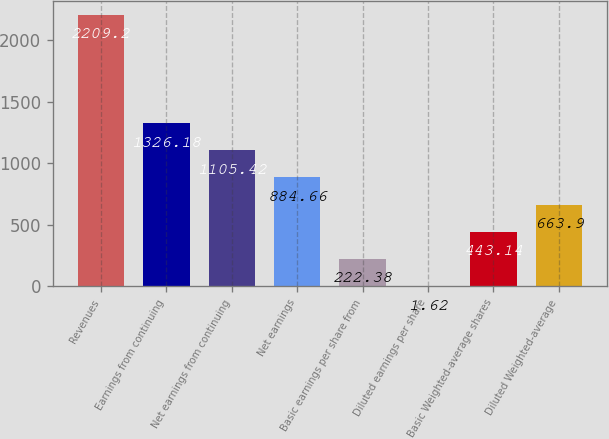Convert chart to OTSL. <chart><loc_0><loc_0><loc_500><loc_500><bar_chart><fcel>Revenues<fcel>Earnings from continuing<fcel>Net earnings from continuing<fcel>Net earnings<fcel>Basic earnings per share from<fcel>Diluted earnings per share<fcel>Basic Weighted-average shares<fcel>Diluted Weighted-average<nl><fcel>2209.2<fcel>1326.18<fcel>1105.42<fcel>884.66<fcel>222.38<fcel>1.62<fcel>443.14<fcel>663.9<nl></chart> 